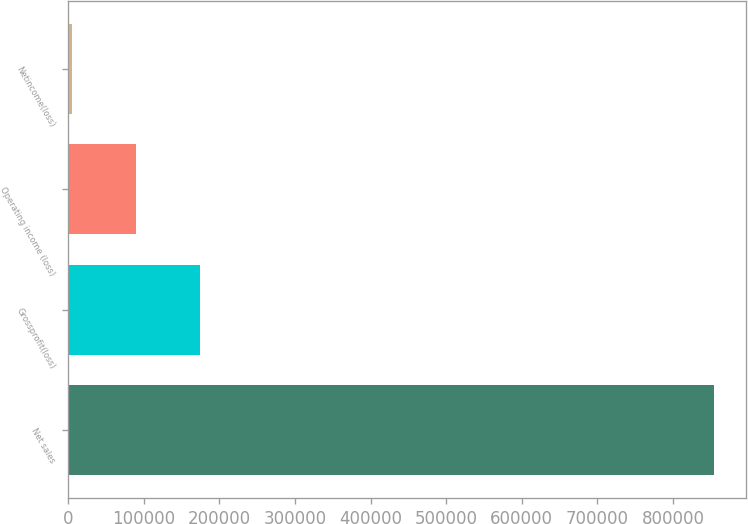<chart> <loc_0><loc_0><loc_500><loc_500><bar_chart><fcel>Net sales<fcel>Grossprofit(loss)<fcel>Operating income (loss)<fcel>Netincome(loss)<nl><fcel>854199<fcel>174881<fcel>89965.8<fcel>5051<nl></chart> 